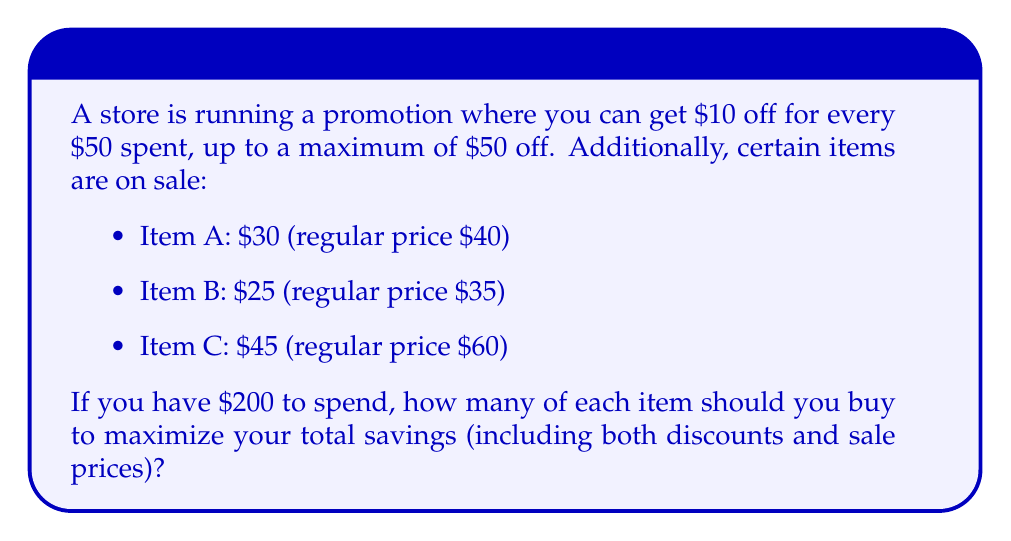Provide a solution to this math problem. Let's approach this step-by-step:

1) First, let's define variables:
   $x$ = number of Item A
   $y$ = number of Item B
   $z$ = number of Item C

2) The total spent must be $200 or less:
   $$30x + 25y + 45z \leq 200$$

3) To maximize the promotion discount, we want the total to be as close to $200 as possible, ideally exactly $200.

4) The savings from sale prices are:
   Item A: $10 per item
   Item B: $10 per item
   Item C: $15 per item

5) Total savings from sale prices:
   $$10x + 10y + 15z$$

6) The promotion discount is based on multiples of $50 spent, up to $50 off:
   $$\min(50, \lfloor \frac{30x + 25y + 45z}{50} \rfloor \times 10)$$

7) Our goal is to maximize:
   $$10x + 10y + 15z + \min(50, \lfloor \frac{30x + 25y + 45z}{50} \rfloor \times 10)$$

8) To get the maximum $50 off from the promotion, we need to spend exactly $200.

9) The combination that maximizes savings while spending exactly $200 is:
   4 of Item C (4 × $45 = $180)
   1 of Item A (1 × $30 = $30)
   Total: $210

10) This combination gives:
    Sale savings: (4 × $15) + (1 × $10) = $70
    Promotion discount: $50
    Total savings: $120

11) No other combination spending $200 or less can yield higher total savings.
Answer: 4 of Item C, 1 of Item A 